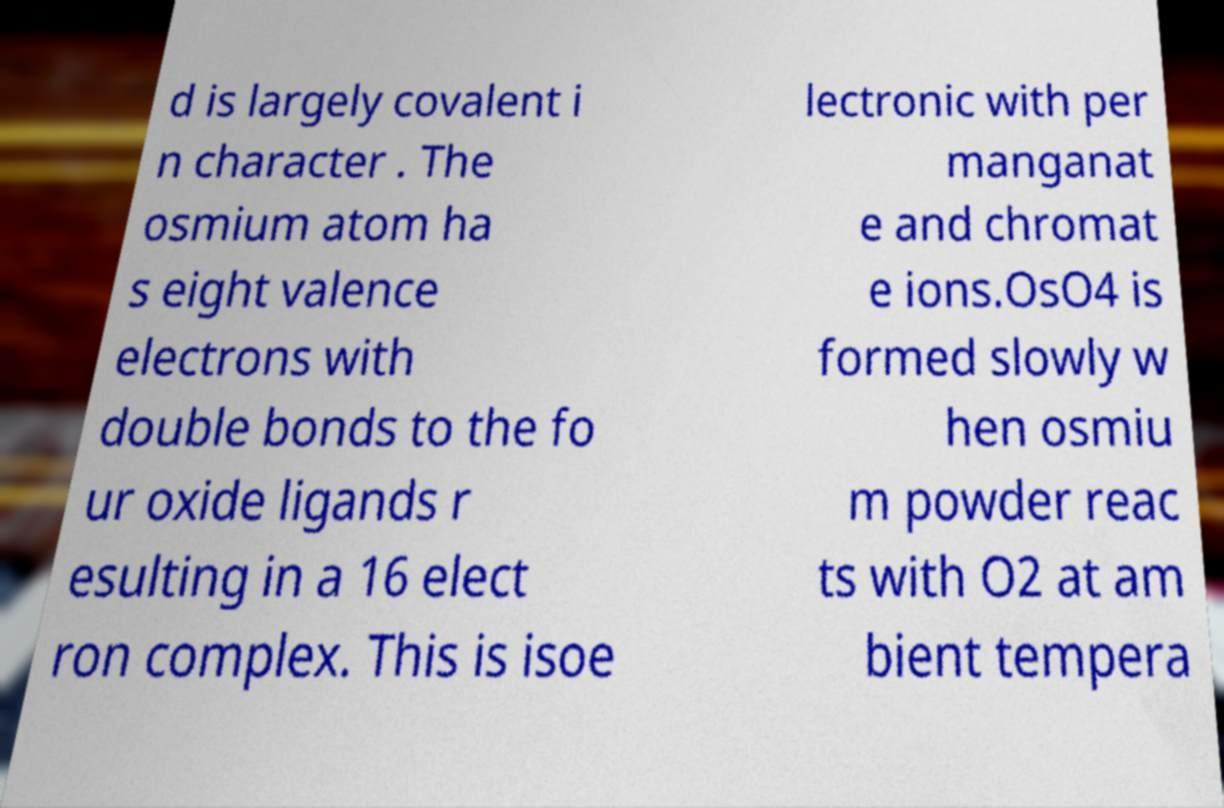There's text embedded in this image that I need extracted. Can you transcribe it verbatim? d is largely covalent i n character . The osmium atom ha s eight valence electrons with double bonds to the fo ur oxide ligands r esulting in a 16 elect ron complex. This is isoe lectronic with per manganat e and chromat e ions.OsO4 is formed slowly w hen osmiu m powder reac ts with O2 at am bient tempera 